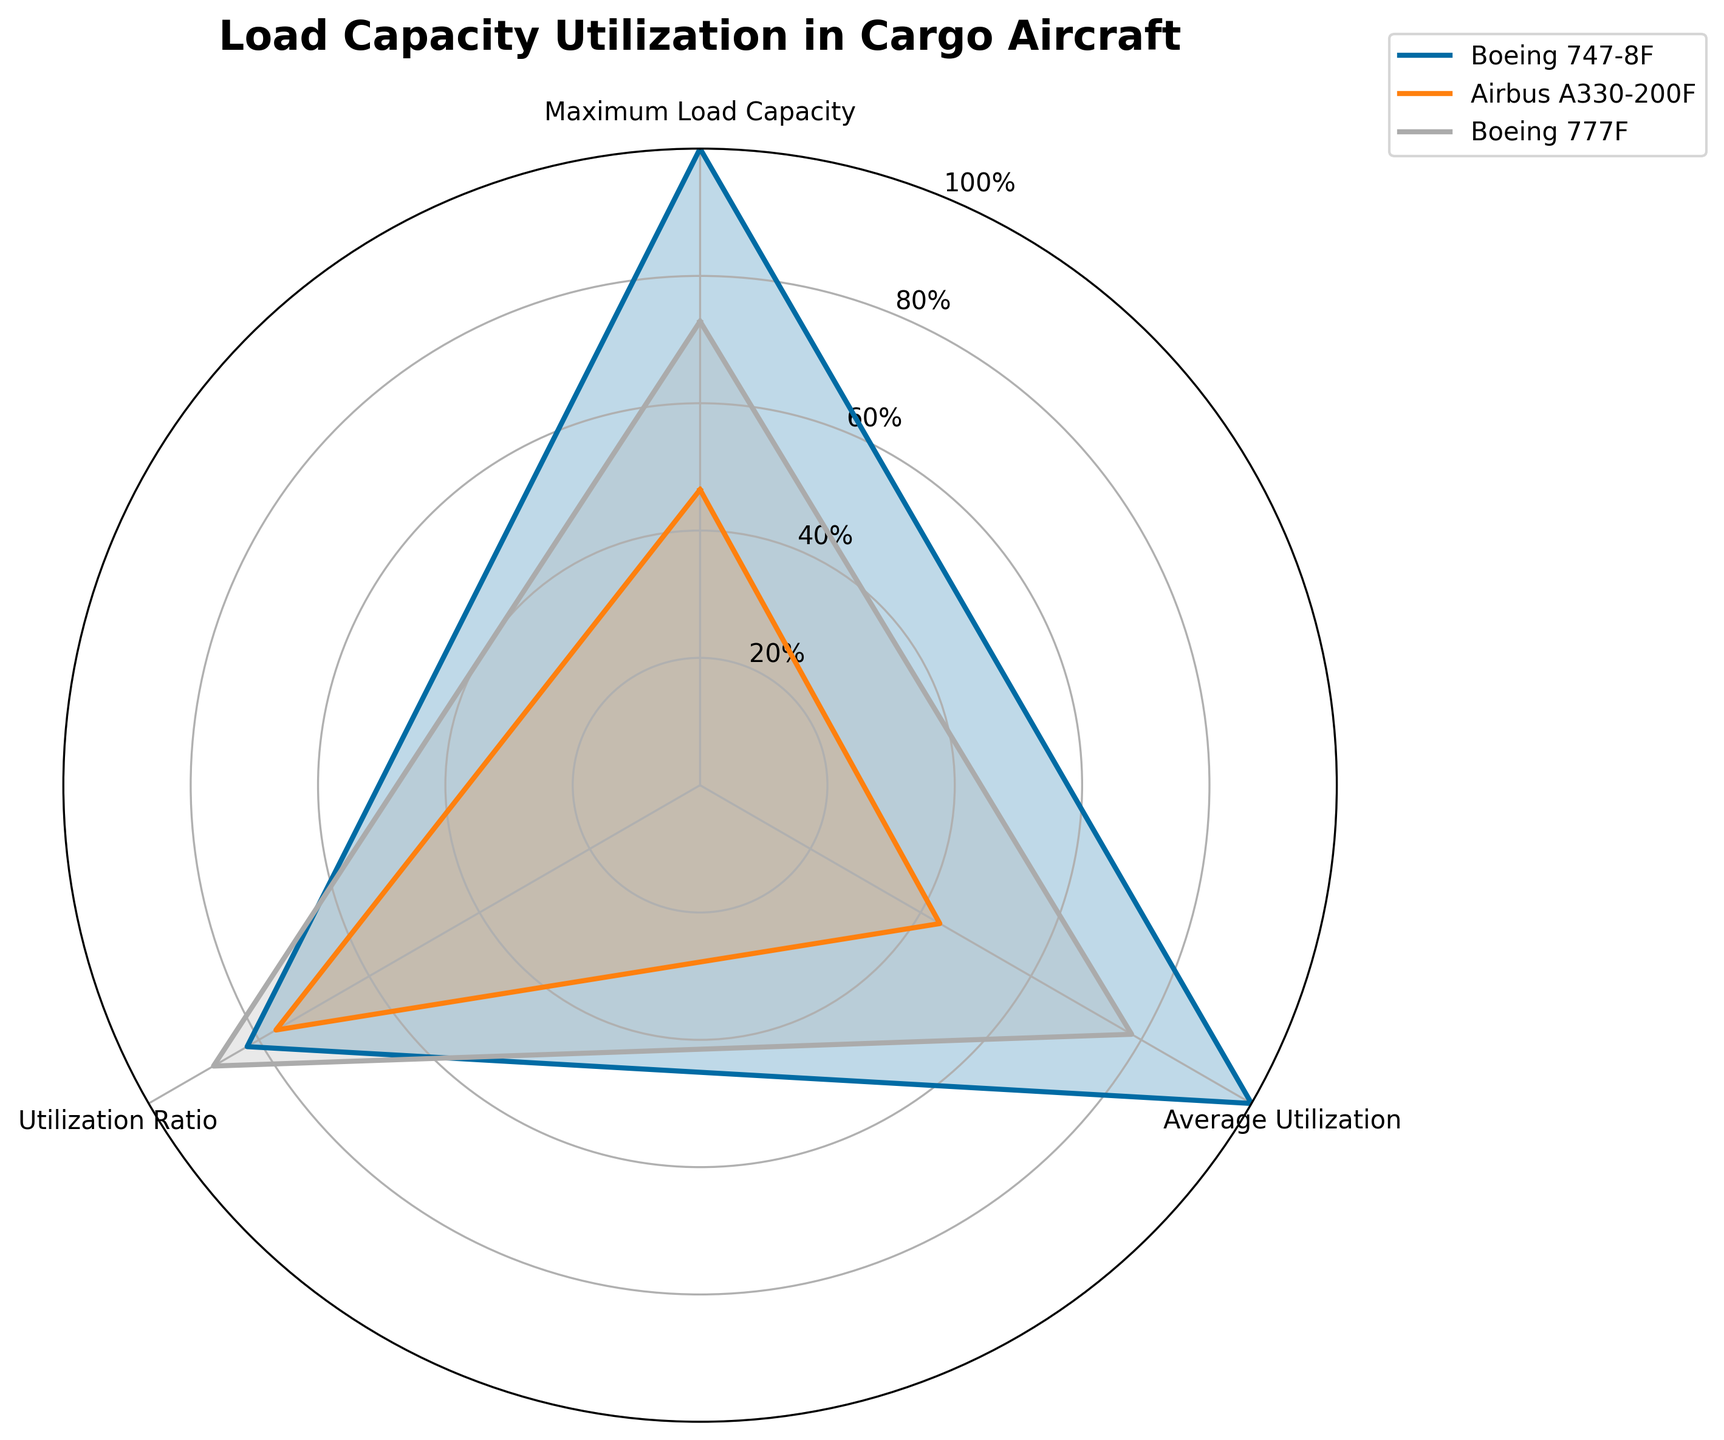What is the title of the radar chart? The title of the radar chart can be directly read from the top of the figure. It states the main topic the chart is representing.
Answer: Load Capacity Utilization in Cargo Aircraft How many aircraft are compared in the radar chart? By counting the number of distinct labels (or lines) in the legend provided in the upper right corner, we can determine the number of compared aircraft.
Answer: 3 Which aircraft has the highest Average Utilization in the radar chart? By inspecting the 'Average Utilization' axis of the radar chart and comparing the lines, the aircraft with the highest value is identified.
Answer: Boeing 777F Compare the Utilization Ratios of Boeing 747-8F and Airbus A330-200F. Which one is higher? By looking at the 'Utilization Ratio' values along the respective axis, the aircraft with the higher value can be determined.
Answer: Boeing 747-8F What is the range of the y-axis in the radar chart? Analyzing the radial grids' labels, which denote the range of values, the minimum and maximum values can be identified.
Answer: 0% to 100% Which aircraft has the lowest Maximum Load Capacity as represented in the radar chart? By comparing the 'Maximum Load Capacity' values of each aircraft, the one with the lowest value is determined.
Answer: Airbus A330-200F On the radar chart, which aircraft’s data forms the largest enclosed area? By visually inspecting the radar chart, the aircraft whose connected lines form the largest enclosed area within the chart can be identified.
Answer: Boeing 777F What is the difference in the Utilization Ratios between Boeing 777F and McDonnell Douglas MD-11F? Subtract the 'Utilization Ratio' value of McDonnell Douglas MD-11F from that of Boeing 777F.
Answer: 12.97% How does the Average Utilization of Boeing 747-8F compare to that of Airbus A330-200F? Look at both 'Average Utilization' values and compare them directly to see which is higher or lower.
Answer: Higher Given the available data in the radar chart, which aircraft shows the most balanced performance across all three categories? To determine balance, observe the evenness of the distances from the center to the points of an aircraft's line on all three axes. Balance implies less variation between categories.
Answer: Boeing 777F 